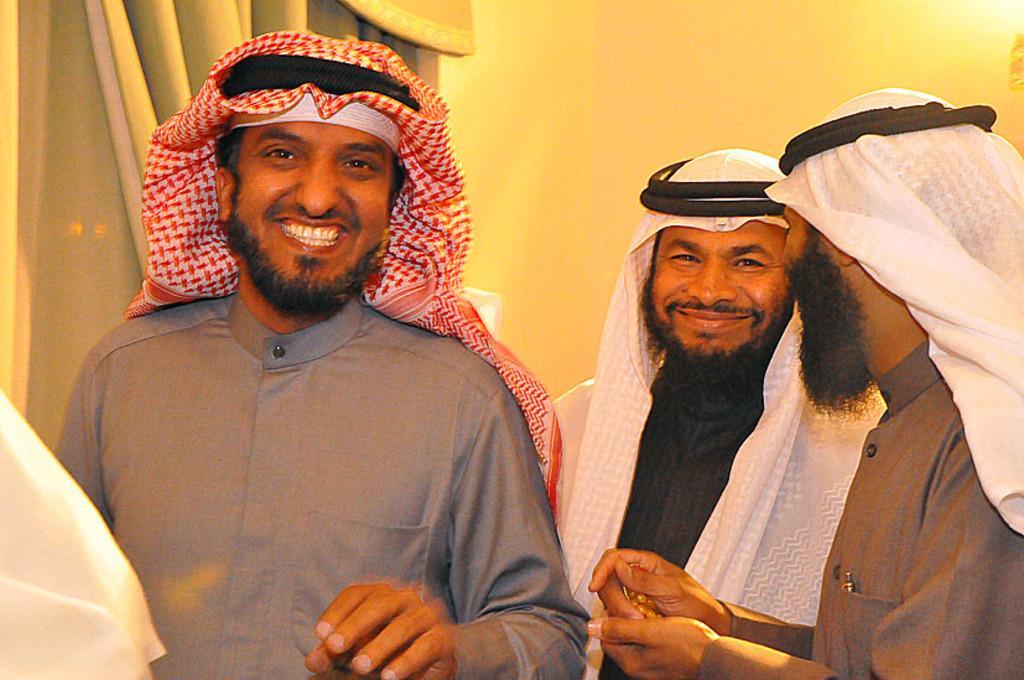Can you describe this image briefly? In this image there are three Arabs standing and talking with each other. In the background there is a curtain on the left side and a wall on the right side. They are laughing. 